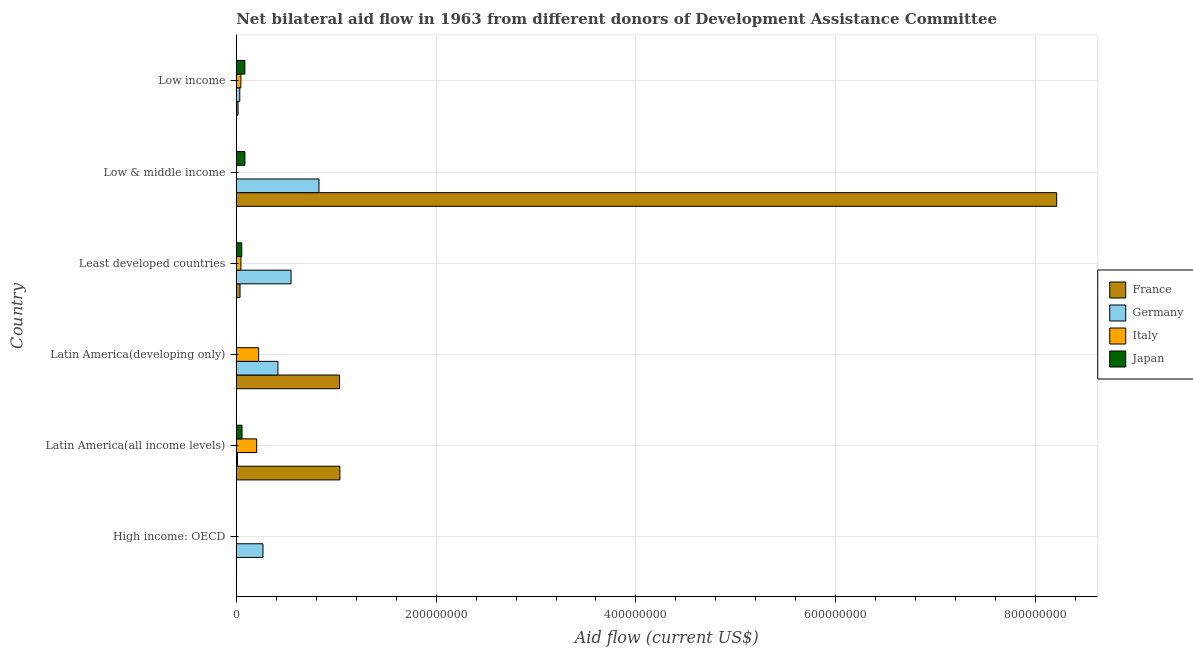How many different coloured bars are there?
Offer a terse response. 4. Are the number of bars on each tick of the Y-axis equal?
Give a very brief answer. Yes. How many bars are there on the 1st tick from the top?
Give a very brief answer. 4. How many bars are there on the 6th tick from the bottom?
Your response must be concise. 4. What is the label of the 3rd group of bars from the top?
Make the answer very short. Least developed countries. What is the amount of aid given by italy in Low income?
Offer a very short reply. 4.62e+06. Across all countries, what is the maximum amount of aid given by germany?
Offer a terse response. 8.28e+07. Across all countries, what is the minimum amount of aid given by japan?
Provide a short and direct response. 2.20e+05. In which country was the amount of aid given by germany minimum?
Your answer should be very brief. Latin America(all income levels). What is the total amount of aid given by france in the graph?
Make the answer very short. 1.03e+09. What is the difference between the amount of aid given by italy in Latin America(all income levels) and that in Latin America(developing only)?
Offer a very short reply. -1.97e+06. What is the difference between the amount of aid given by france in Low & middle income and the amount of aid given by italy in Low income?
Your answer should be compact. 8.16e+08. What is the average amount of aid given by france per country?
Provide a short and direct response. 1.72e+08. What is the difference between the amount of aid given by france and amount of aid given by italy in Least developed countries?
Provide a short and direct response. -8.70e+05. What is the ratio of the amount of aid given by germany in High income: OECD to that in Least developed countries?
Give a very brief answer. 0.49. Is the amount of aid given by italy in High income: OECD less than that in Least developed countries?
Your response must be concise. Yes. Is the difference between the amount of aid given by germany in Low & middle income and Low income greater than the difference between the amount of aid given by italy in Low & middle income and Low income?
Your answer should be very brief. Yes. What is the difference between the highest and the second highest amount of aid given by italy?
Ensure brevity in your answer.  1.97e+06. What is the difference between the highest and the lowest amount of aid given by japan?
Make the answer very short. 8.43e+06. In how many countries, is the amount of aid given by japan greater than the average amount of aid given by japan taken over all countries?
Provide a short and direct response. 4. Is it the case that in every country, the sum of the amount of aid given by germany and amount of aid given by france is greater than the sum of amount of aid given by italy and amount of aid given by japan?
Make the answer very short. Yes. Are all the bars in the graph horizontal?
Keep it short and to the point. Yes. Are the values on the major ticks of X-axis written in scientific E-notation?
Offer a terse response. No. How many legend labels are there?
Provide a short and direct response. 4. How are the legend labels stacked?
Ensure brevity in your answer.  Vertical. What is the title of the graph?
Make the answer very short. Net bilateral aid flow in 1963 from different donors of Development Assistance Committee. What is the Aid flow (current US$) in Germany in High income: OECD?
Offer a very short reply. 2.67e+07. What is the Aid flow (current US$) of France in Latin America(all income levels)?
Provide a short and direct response. 1.04e+08. What is the Aid flow (current US$) of Germany in Latin America(all income levels)?
Your response must be concise. 1.28e+06. What is the Aid flow (current US$) of Italy in Latin America(all income levels)?
Your answer should be compact. 2.04e+07. What is the Aid flow (current US$) in Japan in Latin America(all income levels)?
Your answer should be compact. 5.76e+06. What is the Aid flow (current US$) of France in Latin America(developing only)?
Your answer should be compact. 1.03e+08. What is the Aid flow (current US$) in Germany in Latin America(developing only)?
Provide a short and direct response. 4.17e+07. What is the Aid flow (current US$) in Italy in Latin America(developing only)?
Your response must be concise. 2.24e+07. What is the Aid flow (current US$) of France in Least developed countries?
Your response must be concise. 3.80e+06. What is the Aid flow (current US$) of Germany in Least developed countries?
Make the answer very short. 5.49e+07. What is the Aid flow (current US$) in Italy in Least developed countries?
Ensure brevity in your answer.  4.67e+06. What is the Aid flow (current US$) of Japan in Least developed countries?
Your answer should be very brief. 5.51e+06. What is the Aid flow (current US$) in France in Low & middle income?
Give a very brief answer. 8.21e+08. What is the Aid flow (current US$) of Germany in Low & middle income?
Make the answer very short. 8.28e+07. What is the Aid flow (current US$) of Japan in Low & middle income?
Your answer should be compact. 8.65e+06. What is the Aid flow (current US$) in France in Low income?
Your answer should be compact. 1.80e+06. What is the Aid flow (current US$) in Germany in Low income?
Provide a short and direct response. 3.53e+06. What is the Aid flow (current US$) of Italy in Low income?
Make the answer very short. 4.62e+06. What is the Aid flow (current US$) of Japan in Low income?
Your answer should be very brief. 8.62e+06. Across all countries, what is the maximum Aid flow (current US$) in France?
Give a very brief answer. 8.21e+08. Across all countries, what is the maximum Aid flow (current US$) in Germany?
Provide a succinct answer. 8.28e+07. Across all countries, what is the maximum Aid flow (current US$) of Italy?
Your response must be concise. 2.24e+07. Across all countries, what is the maximum Aid flow (current US$) in Japan?
Keep it short and to the point. 8.65e+06. Across all countries, what is the minimum Aid flow (current US$) in Germany?
Your answer should be compact. 1.28e+06. Across all countries, what is the minimum Aid flow (current US$) of Japan?
Your response must be concise. 2.20e+05. What is the total Aid flow (current US$) of France in the graph?
Your answer should be compact. 1.03e+09. What is the total Aid flow (current US$) in Germany in the graph?
Ensure brevity in your answer.  2.11e+08. What is the total Aid flow (current US$) in Italy in the graph?
Offer a very short reply. 5.23e+07. What is the total Aid flow (current US$) in Japan in the graph?
Ensure brevity in your answer.  2.90e+07. What is the difference between the Aid flow (current US$) of France in High income: OECD and that in Latin America(all income levels)?
Offer a very short reply. -1.03e+08. What is the difference between the Aid flow (current US$) of Germany in High income: OECD and that in Latin America(all income levels)?
Your answer should be compact. 2.55e+07. What is the difference between the Aid flow (current US$) of Italy in High income: OECD and that in Latin America(all income levels)?
Your response must be concise. -2.04e+07. What is the difference between the Aid flow (current US$) in Japan in High income: OECD and that in Latin America(all income levels)?
Give a very brief answer. -5.54e+06. What is the difference between the Aid flow (current US$) in France in High income: OECD and that in Latin America(developing only)?
Offer a terse response. -1.03e+08. What is the difference between the Aid flow (current US$) of Germany in High income: OECD and that in Latin America(developing only)?
Give a very brief answer. -1.50e+07. What is the difference between the Aid flow (current US$) in Italy in High income: OECD and that in Latin America(developing only)?
Offer a terse response. -2.23e+07. What is the difference between the Aid flow (current US$) in Japan in High income: OECD and that in Latin America(developing only)?
Provide a succinct answer. -3.00e+04. What is the difference between the Aid flow (current US$) in France in High income: OECD and that in Least developed countries?
Your answer should be very brief. -3.50e+06. What is the difference between the Aid flow (current US$) in Germany in High income: OECD and that in Least developed countries?
Offer a very short reply. -2.81e+07. What is the difference between the Aid flow (current US$) in Italy in High income: OECD and that in Least developed countries?
Offer a very short reply. -4.59e+06. What is the difference between the Aid flow (current US$) of Japan in High income: OECD and that in Least developed countries?
Offer a terse response. -5.29e+06. What is the difference between the Aid flow (current US$) in France in High income: OECD and that in Low & middle income?
Your response must be concise. -8.21e+08. What is the difference between the Aid flow (current US$) of Germany in High income: OECD and that in Low & middle income?
Provide a short and direct response. -5.61e+07. What is the difference between the Aid flow (current US$) of Italy in High income: OECD and that in Low & middle income?
Ensure brevity in your answer.  3.00e+04. What is the difference between the Aid flow (current US$) in Japan in High income: OECD and that in Low & middle income?
Offer a terse response. -8.43e+06. What is the difference between the Aid flow (current US$) of France in High income: OECD and that in Low income?
Make the answer very short. -1.50e+06. What is the difference between the Aid flow (current US$) in Germany in High income: OECD and that in Low income?
Provide a short and direct response. 2.32e+07. What is the difference between the Aid flow (current US$) of Italy in High income: OECD and that in Low income?
Keep it short and to the point. -4.54e+06. What is the difference between the Aid flow (current US$) in Japan in High income: OECD and that in Low income?
Offer a very short reply. -8.40e+06. What is the difference between the Aid flow (current US$) in France in Latin America(all income levels) and that in Latin America(developing only)?
Provide a short and direct response. 3.00e+05. What is the difference between the Aid flow (current US$) in Germany in Latin America(all income levels) and that in Latin America(developing only)?
Provide a succinct answer. -4.04e+07. What is the difference between the Aid flow (current US$) of Italy in Latin America(all income levels) and that in Latin America(developing only)?
Give a very brief answer. -1.97e+06. What is the difference between the Aid flow (current US$) of Japan in Latin America(all income levels) and that in Latin America(developing only)?
Keep it short and to the point. 5.51e+06. What is the difference between the Aid flow (current US$) in France in Latin America(all income levels) and that in Least developed countries?
Your response must be concise. 9.99e+07. What is the difference between the Aid flow (current US$) of Germany in Latin America(all income levels) and that in Least developed countries?
Provide a short and direct response. -5.36e+07. What is the difference between the Aid flow (current US$) of Italy in Latin America(all income levels) and that in Least developed countries?
Ensure brevity in your answer.  1.58e+07. What is the difference between the Aid flow (current US$) in Japan in Latin America(all income levels) and that in Least developed countries?
Your answer should be very brief. 2.50e+05. What is the difference between the Aid flow (current US$) of France in Latin America(all income levels) and that in Low & middle income?
Make the answer very short. -7.17e+08. What is the difference between the Aid flow (current US$) in Germany in Latin America(all income levels) and that in Low & middle income?
Provide a short and direct response. -8.15e+07. What is the difference between the Aid flow (current US$) in Italy in Latin America(all income levels) and that in Low & middle income?
Your answer should be compact. 2.04e+07. What is the difference between the Aid flow (current US$) of Japan in Latin America(all income levels) and that in Low & middle income?
Offer a terse response. -2.89e+06. What is the difference between the Aid flow (current US$) of France in Latin America(all income levels) and that in Low income?
Your answer should be compact. 1.02e+08. What is the difference between the Aid flow (current US$) of Germany in Latin America(all income levels) and that in Low income?
Provide a succinct answer. -2.25e+06. What is the difference between the Aid flow (current US$) of Italy in Latin America(all income levels) and that in Low income?
Offer a terse response. 1.58e+07. What is the difference between the Aid flow (current US$) of Japan in Latin America(all income levels) and that in Low income?
Offer a very short reply. -2.86e+06. What is the difference between the Aid flow (current US$) of France in Latin America(developing only) and that in Least developed countries?
Make the answer very short. 9.96e+07. What is the difference between the Aid flow (current US$) in Germany in Latin America(developing only) and that in Least developed countries?
Give a very brief answer. -1.32e+07. What is the difference between the Aid flow (current US$) of Italy in Latin America(developing only) and that in Least developed countries?
Your answer should be very brief. 1.78e+07. What is the difference between the Aid flow (current US$) in Japan in Latin America(developing only) and that in Least developed countries?
Offer a terse response. -5.26e+06. What is the difference between the Aid flow (current US$) of France in Latin America(developing only) and that in Low & middle income?
Give a very brief answer. -7.18e+08. What is the difference between the Aid flow (current US$) in Germany in Latin America(developing only) and that in Low & middle income?
Make the answer very short. -4.11e+07. What is the difference between the Aid flow (current US$) in Italy in Latin America(developing only) and that in Low & middle income?
Your response must be concise. 2.24e+07. What is the difference between the Aid flow (current US$) in Japan in Latin America(developing only) and that in Low & middle income?
Offer a very short reply. -8.40e+06. What is the difference between the Aid flow (current US$) in France in Latin America(developing only) and that in Low income?
Offer a terse response. 1.02e+08. What is the difference between the Aid flow (current US$) in Germany in Latin America(developing only) and that in Low income?
Ensure brevity in your answer.  3.82e+07. What is the difference between the Aid flow (current US$) of Italy in Latin America(developing only) and that in Low income?
Offer a terse response. 1.78e+07. What is the difference between the Aid flow (current US$) in Japan in Latin America(developing only) and that in Low income?
Make the answer very short. -8.37e+06. What is the difference between the Aid flow (current US$) of France in Least developed countries and that in Low & middle income?
Ensure brevity in your answer.  -8.17e+08. What is the difference between the Aid flow (current US$) in Germany in Least developed countries and that in Low & middle income?
Your answer should be compact. -2.79e+07. What is the difference between the Aid flow (current US$) in Italy in Least developed countries and that in Low & middle income?
Ensure brevity in your answer.  4.62e+06. What is the difference between the Aid flow (current US$) in Japan in Least developed countries and that in Low & middle income?
Keep it short and to the point. -3.14e+06. What is the difference between the Aid flow (current US$) in France in Least developed countries and that in Low income?
Your response must be concise. 2.00e+06. What is the difference between the Aid flow (current US$) in Germany in Least developed countries and that in Low income?
Offer a very short reply. 5.13e+07. What is the difference between the Aid flow (current US$) of Italy in Least developed countries and that in Low income?
Offer a terse response. 5.00e+04. What is the difference between the Aid flow (current US$) of Japan in Least developed countries and that in Low income?
Your response must be concise. -3.11e+06. What is the difference between the Aid flow (current US$) of France in Low & middle income and that in Low income?
Offer a terse response. 8.19e+08. What is the difference between the Aid flow (current US$) in Germany in Low & middle income and that in Low income?
Your answer should be very brief. 7.93e+07. What is the difference between the Aid flow (current US$) in Italy in Low & middle income and that in Low income?
Keep it short and to the point. -4.57e+06. What is the difference between the Aid flow (current US$) in France in High income: OECD and the Aid flow (current US$) in Germany in Latin America(all income levels)?
Keep it short and to the point. -9.80e+05. What is the difference between the Aid flow (current US$) of France in High income: OECD and the Aid flow (current US$) of Italy in Latin America(all income levels)?
Provide a succinct answer. -2.02e+07. What is the difference between the Aid flow (current US$) in France in High income: OECD and the Aid flow (current US$) in Japan in Latin America(all income levels)?
Your response must be concise. -5.46e+06. What is the difference between the Aid flow (current US$) in Germany in High income: OECD and the Aid flow (current US$) in Italy in Latin America(all income levels)?
Give a very brief answer. 6.29e+06. What is the difference between the Aid flow (current US$) of Germany in High income: OECD and the Aid flow (current US$) of Japan in Latin America(all income levels)?
Your answer should be very brief. 2.10e+07. What is the difference between the Aid flow (current US$) of Italy in High income: OECD and the Aid flow (current US$) of Japan in Latin America(all income levels)?
Your answer should be very brief. -5.68e+06. What is the difference between the Aid flow (current US$) in France in High income: OECD and the Aid flow (current US$) in Germany in Latin America(developing only)?
Give a very brief answer. -4.14e+07. What is the difference between the Aid flow (current US$) in France in High income: OECD and the Aid flow (current US$) in Italy in Latin America(developing only)?
Make the answer very short. -2.21e+07. What is the difference between the Aid flow (current US$) of Germany in High income: OECD and the Aid flow (current US$) of Italy in Latin America(developing only)?
Provide a succinct answer. 4.32e+06. What is the difference between the Aid flow (current US$) in Germany in High income: OECD and the Aid flow (current US$) in Japan in Latin America(developing only)?
Give a very brief answer. 2.65e+07. What is the difference between the Aid flow (current US$) in France in High income: OECD and the Aid flow (current US$) in Germany in Least developed countries?
Offer a terse response. -5.46e+07. What is the difference between the Aid flow (current US$) in France in High income: OECD and the Aid flow (current US$) in Italy in Least developed countries?
Offer a terse response. -4.37e+06. What is the difference between the Aid flow (current US$) in France in High income: OECD and the Aid flow (current US$) in Japan in Least developed countries?
Your answer should be compact. -5.21e+06. What is the difference between the Aid flow (current US$) in Germany in High income: OECD and the Aid flow (current US$) in Italy in Least developed countries?
Provide a succinct answer. 2.21e+07. What is the difference between the Aid flow (current US$) of Germany in High income: OECD and the Aid flow (current US$) of Japan in Least developed countries?
Keep it short and to the point. 2.12e+07. What is the difference between the Aid flow (current US$) of Italy in High income: OECD and the Aid flow (current US$) of Japan in Least developed countries?
Provide a succinct answer. -5.43e+06. What is the difference between the Aid flow (current US$) of France in High income: OECD and the Aid flow (current US$) of Germany in Low & middle income?
Provide a succinct answer. -8.25e+07. What is the difference between the Aid flow (current US$) in France in High income: OECD and the Aid flow (current US$) in Japan in Low & middle income?
Keep it short and to the point. -8.35e+06. What is the difference between the Aid flow (current US$) in Germany in High income: OECD and the Aid flow (current US$) in Italy in Low & middle income?
Provide a short and direct response. 2.67e+07. What is the difference between the Aid flow (current US$) in Germany in High income: OECD and the Aid flow (current US$) in Japan in Low & middle income?
Offer a terse response. 1.81e+07. What is the difference between the Aid flow (current US$) of Italy in High income: OECD and the Aid flow (current US$) of Japan in Low & middle income?
Ensure brevity in your answer.  -8.57e+06. What is the difference between the Aid flow (current US$) of France in High income: OECD and the Aid flow (current US$) of Germany in Low income?
Provide a succinct answer. -3.23e+06. What is the difference between the Aid flow (current US$) of France in High income: OECD and the Aid flow (current US$) of Italy in Low income?
Keep it short and to the point. -4.32e+06. What is the difference between the Aid flow (current US$) of France in High income: OECD and the Aid flow (current US$) of Japan in Low income?
Give a very brief answer. -8.32e+06. What is the difference between the Aid flow (current US$) in Germany in High income: OECD and the Aid flow (current US$) in Italy in Low income?
Offer a very short reply. 2.21e+07. What is the difference between the Aid flow (current US$) of Germany in High income: OECD and the Aid flow (current US$) of Japan in Low income?
Give a very brief answer. 1.81e+07. What is the difference between the Aid flow (current US$) in Italy in High income: OECD and the Aid flow (current US$) in Japan in Low income?
Offer a very short reply. -8.54e+06. What is the difference between the Aid flow (current US$) of France in Latin America(all income levels) and the Aid flow (current US$) of Germany in Latin America(developing only)?
Keep it short and to the point. 6.20e+07. What is the difference between the Aid flow (current US$) in France in Latin America(all income levels) and the Aid flow (current US$) in Italy in Latin America(developing only)?
Your answer should be compact. 8.13e+07. What is the difference between the Aid flow (current US$) in France in Latin America(all income levels) and the Aid flow (current US$) in Japan in Latin America(developing only)?
Offer a very short reply. 1.03e+08. What is the difference between the Aid flow (current US$) of Germany in Latin America(all income levels) and the Aid flow (current US$) of Italy in Latin America(developing only)?
Offer a very short reply. -2.11e+07. What is the difference between the Aid flow (current US$) in Germany in Latin America(all income levels) and the Aid flow (current US$) in Japan in Latin America(developing only)?
Give a very brief answer. 1.03e+06. What is the difference between the Aid flow (current US$) in Italy in Latin America(all income levels) and the Aid flow (current US$) in Japan in Latin America(developing only)?
Offer a terse response. 2.02e+07. What is the difference between the Aid flow (current US$) in France in Latin America(all income levels) and the Aid flow (current US$) in Germany in Least developed countries?
Provide a succinct answer. 4.88e+07. What is the difference between the Aid flow (current US$) in France in Latin America(all income levels) and the Aid flow (current US$) in Italy in Least developed countries?
Make the answer very short. 9.90e+07. What is the difference between the Aid flow (current US$) of France in Latin America(all income levels) and the Aid flow (current US$) of Japan in Least developed countries?
Offer a terse response. 9.82e+07. What is the difference between the Aid flow (current US$) of Germany in Latin America(all income levels) and the Aid flow (current US$) of Italy in Least developed countries?
Your answer should be very brief. -3.39e+06. What is the difference between the Aid flow (current US$) of Germany in Latin America(all income levels) and the Aid flow (current US$) of Japan in Least developed countries?
Provide a succinct answer. -4.23e+06. What is the difference between the Aid flow (current US$) in Italy in Latin America(all income levels) and the Aid flow (current US$) in Japan in Least developed countries?
Ensure brevity in your answer.  1.49e+07. What is the difference between the Aid flow (current US$) in France in Latin America(all income levels) and the Aid flow (current US$) in Germany in Low & middle income?
Give a very brief answer. 2.09e+07. What is the difference between the Aid flow (current US$) in France in Latin America(all income levels) and the Aid flow (current US$) in Italy in Low & middle income?
Your response must be concise. 1.04e+08. What is the difference between the Aid flow (current US$) of France in Latin America(all income levels) and the Aid flow (current US$) of Japan in Low & middle income?
Provide a short and direct response. 9.50e+07. What is the difference between the Aid flow (current US$) of Germany in Latin America(all income levels) and the Aid flow (current US$) of Italy in Low & middle income?
Your response must be concise. 1.23e+06. What is the difference between the Aid flow (current US$) in Germany in Latin America(all income levels) and the Aid flow (current US$) in Japan in Low & middle income?
Make the answer very short. -7.37e+06. What is the difference between the Aid flow (current US$) in Italy in Latin America(all income levels) and the Aid flow (current US$) in Japan in Low & middle income?
Keep it short and to the point. 1.18e+07. What is the difference between the Aid flow (current US$) of France in Latin America(all income levels) and the Aid flow (current US$) of Germany in Low income?
Keep it short and to the point. 1.00e+08. What is the difference between the Aid flow (current US$) of France in Latin America(all income levels) and the Aid flow (current US$) of Italy in Low income?
Provide a succinct answer. 9.91e+07. What is the difference between the Aid flow (current US$) in France in Latin America(all income levels) and the Aid flow (current US$) in Japan in Low income?
Give a very brief answer. 9.51e+07. What is the difference between the Aid flow (current US$) in Germany in Latin America(all income levels) and the Aid flow (current US$) in Italy in Low income?
Your answer should be compact. -3.34e+06. What is the difference between the Aid flow (current US$) of Germany in Latin America(all income levels) and the Aid flow (current US$) of Japan in Low income?
Provide a short and direct response. -7.34e+06. What is the difference between the Aid flow (current US$) in Italy in Latin America(all income levels) and the Aid flow (current US$) in Japan in Low income?
Provide a succinct answer. 1.18e+07. What is the difference between the Aid flow (current US$) of France in Latin America(developing only) and the Aid flow (current US$) of Germany in Least developed countries?
Ensure brevity in your answer.  4.85e+07. What is the difference between the Aid flow (current US$) of France in Latin America(developing only) and the Aid flow (current US$) of Italy in Least developed countries?
Offer a terse response. 9.87e+07. What is the difference between the Aid flow (current US$) in France in Latin America(developing only) and the Aid flow (current US$) in Japan in Least developed countries?
Keep it short and to the point. 9.79e+07. What is the difference between the Aid flow (current US$) in Germany in Latin America(developing only) and the Aid flow (current US$) in Italy in Least developed countries?
Offer a very short reply. 3.70e+07. What is the difference between the Aid flow (current US$) of Germany in Latin America(developing only) and the Aid flow (current US$) of Japan in Least developed countries?
Your answer should be compact. 3.62e+07. What is the difference between the Aid flow (current US$) of Italy in Latin America(developing only) and the Aid flow (current US$) of Japan in Least developed countries?
Give a very brief answer. 1.69e+07. What is the difference between the Aid flow (current US$) of France in Latin America(developing only) and the Aid flow (current US$) of Germany in Low & middle income?
Your answer should be very brief. 2.06e+07. What is the difference between the Aid flow (current US$) of France in Latin America(developing only) and the Aid flow (current US$) of Italy in Low & middle income?
Your answer should be very brief. 1.03e+08. What is the difference between the Aid flow (current US$) of France in Latin America(developing only) and the Aid flow (current US$) of Japan in Low & middle income?
Give a very brief answer. 9.48e+07. What is the difference between the Aid flow (current US$) in Germany in Latin America(developing only) and the Aid flow (current US$) in Italy in Low & middle income?
Your response must be concise. 4.16e+07. What is the difference between the Aid flow (current US$) in Germany in Latin America(developing only) and the Aid flow (current US$) in Japan in Low & middle income?
Provide a short and direct response. 3.30e+07. What is the difference between the Aid flow (current US$) of Italy in Latin America(developing only) and the Aid flow (current US$) of Japan in Low & middle income?
Ensure brevity in your answer.  1.38e+07. What is the difference between the Aid flow (current US$) of France in Latin America(developing only) and the Aid flow (current US$) of Germany in Low income?
Offer a very short reply. 9.99e+07. What is the difference between the Aid flow (current US$) of France in Latin America(developing only) and the Aid flow (current US$) of Italy in Low income?
Your response must be concise. 9.88e+07. What is the difference between the Aid flow (current US$) in France in Latin America(developing only) and the Aid flow (current US$) in Japan in Low income?
Your answer should be very brief. 9.48e+07. What is the difference between the Aid flow (current US$) of Germany in Latin America(developing only) and the Aid flow (current US$) of Italy in Low income?
Give a very brief answer. 3.71e+07. What is the difference between the Aid flow (current US$) in Germany in Latin America(developing only) and the Aid flow (current US$) in Japan in Low income?
Provide a short and direct response. 3.31e+07. What is the difference between the Aid flow (current US$) in Italy in Latin America(developing only) and the Aid flow (current US$) in Japan in Low income?
Keep it short and to the point. 1.38e+07. What is the difference between the Aid flow (current US$) of France in Least developed countries and the Aid flow (current US$) of Germany in Low & middle income?
Ensure brevity in your answer.  -7.90e+07. What is the difference between the Aid flow (current US$) of France in Least developed countries and the Aid flow (current US$) of Italy in Low & middle income?
Your answer should be very brief. 3.75e+06. What is the difference between the Aid flow (current US$) in France in Least developed countries and the Aid flow (current US$) in Japan in Low & middle income?
Your answer should be very brief. -4.85e+06. What is the difference between the Aid flow (current US$) in Germany in Least developed countries and the Aid flow (current US$) in Italy in Low & middle income?
Make the answer very short. 5.48e+07. What is the difference between the Aid flow (current US$) in Germany in Least developed countries and the Aid flow (current US$) in Japan in Low & middle income?
Offer a very short reply. 4.62e+07. What is the difference between the Aid flow (current US$) in Italy in Least developed countries and the Aid flow (current US$) in Japan in Low & middle income?
Your answer should be compact. -3.98e+06. What is the difference between the Aid flow (current US$) of France in Least developed countries and the Aid flow (current US$) of Italy in Low income?
Give a very brief answer. -8.20e+05. What is the difference between the Aid flow (current US$) in France in Least developed countries and the Aid flow (current US$) in Japan in Low income?
Your answer should be very brief. -4.82e+06. What is the difference between the Aid flow (current US$) in Germany in Least developed countries and the Aid flow (current US$) in Italy in Low income?
Keep it short and to the point. 5.02e+07. What is the difference between the Aid flow (current US$) of Germany in Least developed countries and the Aid flow (current US$) of Japan in Low income?
Provide a succinct answer. 4.62e+07. What is the difference between the Aid flow (current US$) in Italy in Least developed countries and the Aid flow (current US$) in Japan in Low income?
Offer a terse response. -3.95e+06. What is the difference between the Aid flow (current US$) of France in Low & middle income and the Aid flow (current US$) of Germany in Low income?
Ensure brevity in your answer.  8.18e+08. What is the difference between the Aid flow (current US$) in France in Low & middle income and the Aid flow (current US$) in Italy in Low income?
Your answer should be very brief. 8.16e+08. What is the difference between the Aid flow (current US$) in France in Low & middle income and the Aid flow (current US$) in Japan in Low income?
Provide a short and direct response. 8.12e+08. What is the difference between the Aid flow (current US$) of Germany in Low & middle income and the Aid flow (current US$) of Italy in Low income?
Offer a very short reply. 7.82e+07. What is the difference between the Aid flow (current US$) in Germany in Low & middle income and the Aid flow (current US$) in Japan in Low income?
Your answer should be very brief. 7.42e+07. What is the difference between the Aid flow (current US$) of Italy in Low & middle income and the Aid flow (current US$) of Japan in Low income?
Your answer should be very brief. -8.57e+06. What is the average Aid flow (current US$) in France per country?
Offer a very short reply. 1.72e+08. What is the average Aid flow (current US$) of Germany per country?
Make the answer very short. 3.52e+07. What is the average Aid flow (current US$) in Italy per country?
Keep it short and to the point. 8.72e+06. What is the average Aid flow (current US$) of Japan per country?
Provide a succinct answer. 4.84e+06. What is the difference between the Aid flow (current US$) of France and Aid flow (current US$) of Germany in High income: OECD?
Provide a succinct answer. -2.64e+07. What is the difference between the Aid flow (current US$) in Germany and Aid flow (current US$) in Italy in High income: OECD?
Give a very brief answer. 2.67e+07. What is the difference between the Aid flow (current US$) of Germany and Aid flow (current US$) of Japan in High income: OECD?
Your answer should be very brief. 2.65e+07. What is the difference between the Aid flow (current US$) in Italy and Aid flow (current US$) in Japan in High income: OECD?
Your answer should be very brief. -1.40e+05. What is the difference between the Aid flow (current US$) in France and Aid flow (current US$) in Germany in Latin America(all income levels)?
Give a very brief answer. 1.02e+08. What is the difference between the Aid flow (current US$) in France and Aid flow (current US$) in Italy in Latin America(all income levels)?
Keep it short and to the point. 8.32e+07. What is the difference between the Aid flow (current US$) in France and Aid flow (current US$) in Japan in Latin America(all income levels)?
Ensure brevity in your answer.  9.79e+07. What is the difference between the Aid flow (current US$) of Germany and Aid flow (current US$) of Italy in Latin America(all income levels)?
Your answer should be compact. -1.92e+07. What is the difference between the Aid flow (current US$) of Germany and Aid flow (current US$) of Japan in Latin America(all income levels)?
Make the answer very short. -4.48e+06. What is the difference between the Aid flow (current US$) in Italy and Aid flow (current US$) in Japan in Latin America(all income levels)?
Provide a succinct answer. 1.47e+07. What is the difference between the Aid flow (current US$) of France and Aid flow (current US$) of Germany in Latin America(developing only)?
Offer a very short reply. 6.17e+07. What is the difference between the Aid flow (current US$) of France and Aid flow (current US$) of Italy in Latin America(developing only)?
Keep it short and to the point. 8.10e+07. What is the difference between the Aid flow (current US$) in France and Aid flow (current US$) in Japan in Latin America(developing only)?
Offer a very short reply. 1.03e+08. What is the difference between the Aid flow (current US$) in Germany and Aid flow (current US$) in Italy in Latin America(developing only)?
Provide a short and direct response. 1.93e+07. What is the difference between the Aid flow (current US$) in Germany and Aid flow (current US$) in Japan in Latin America(developing only)?
Keep it short and to the point. 4.14e+07. What is the difference between the Aid flow (current US$) in Italy and Aid flow (current US$) in Japan in Latin America(developing only)?
Make the answer very short. 2.22e+07. What is the difference between the Aid flow (current US$) of France and Aid flow (current US$) of Germany in Least developed countries?
Offer a very short reply. -5.11e+07. What is the difference between the Aid flow (current US$) in France and Aid flow (current US$) in Italy in Least developed countries?
Give a very brief answer. -8.70e+05. What is the difference between the Aid flow (current US$) in France and Aid flow (current US$) in Japan in Least developed countries?
Make the answer very short. -1.71e+06. What is the difference between the Aid flow (current US$) in Germany and Aid flow (current US$) in Italy in Least developed countries?
Your answer should be very brief. 5.02e+07. What is the difference between the Aid flow (current US$) of Germany and Aid flow (current US$) of Japan in Least developed countries?
Keep it short and to the point. 4.94e+07. What is the difference between the Aid flow (current US$) in Italy and Aid flow (current US$) in Japan in Least developed countries?
Provide a short and direct response. -8.40e+05. What is the difference between the Aid flow (current US$) of France and Aid flow (current US$) of Germany in Low & middle income?
Provide a short and direct response. 7.38e+08. What is the difference between the Aid flow (current US$) of France and Aid flow (current US$) of Italy in Low & middle income?
Your response must be concise. 8.21e+08. What is the difference between the Aid flow (current US$) in France and Aid flow (current US$) in Japan in Low & middle income?
Your answer should be compact. 8.12e+08. What is the difference between the Aid flow (current US$) in Germany and Aid flow (current US$) in Italy in Low & middle income?
Offer a very short reply. 8.28e+07. What is the difference between the Aid flow (current US$) of Germany and Aid flow (current US$) of Japan in Low & middle income?
Provide a short and direct response. 7.42e+07. What is the difference between the Aid flow (current US$) in Italy and Aid flow (current US$) in Japan in Low & middle income?
Your answer should be compact. -8.60e+06. What is the difference between the Aid flow (current US$) in France and Aid flow (current US$) in Germany in Low income?
Your response must be concise. -1.73e+06. What is the difference between the Aid flow (current US$) of France and Aid flow (current US$) of Italy in Low income?
Your answer should be very brief. -2.82e+06. What is the difference between the Aid flow (current US$) in France and Aid flow (current US$) in Japan in Low income?
Provide a succinct answer. -6.82e+06. What is the difference between the Aid flow (current US$) of Germany and Aid flow (current US$) of Italy in Low income?
Your response must be concise. -1.09e+06. What is the difference between the Aid flow (current US$) of Germany and Aid flow (current US$) of Japan in Low income?
Offer a terse response. -5.09e+06. What is the difference between the Aid flow (current US$) of Italy and Aid flow (current US$) of Japan in Low income?
Ensure brevity in your answer.  -4.00e+06. What is the ratio of the Aid flow (current US$) in France in High income: OECD to that in Latin America(all income levels)?
Keep it short and to the point. 0. What is the ratio of the Aid flow (current US$) of Germany in High income: OECD to that in Latin America(all income levels)?
Keep it short and to the point. 20.89. What is the ratio of the Aid flow (current US$) of Italy in High income: OECD to that in Latin America(all income levels)?
Your answer should be very brief. 0. What is the ratio of the Aid flow (current US$) in Japan in High income: OECD to that in Latin America(all income levels)?
Make the answer very short. 0.04. What is the ratio of the Aid flow (current US$) in France in High income: OECD to that in Latin America(developing only)?
Ensure brevity in your answer.  0. What is the ratio of the Aid flow (current US$) in Germany in High income: OECD to that in Latin America(developing only)?
Your answer should be compact. 0.64. What is the ratio of the Aid flow (current US$) of Italy in High income: OECD to that in Latin America(developing only)?
Ensure brevity in your answer.  0. What is the ratio of the Aid flow (current US$) of Japan in High income: OECD to that in Latin America(developing only)?
Provide a short and direct response. 0.88. What is the ratio of the Aid flow (current US$) of France in High income: OECD to that in Least developed countries?
Your answer should be compact. 0.08. What is the ratio of the Aid flow (current US$) of Germany in High income: OECD to that in Least developed countries?
Your answer should be compact. 0.49. What is the ratio of the Aid flow (current US$) of Italy in High income: OECD to that in Least developed countries?
Your response must be concise. 0.02. What is the ratio of the Aid flow (current US$) of Japan in High income: OECD to that in Least developed countries?
Give a very brief answer. 0.04. What is the ratio of the Aid flow (current US$) of France in High income: OECD to that in Low & middle income?
Give a very brief answer. 0. What is the ratio of the Aid flow (current US$) of Germany in High income: OECD to that in Low & middle income?
Offer a terse response. 0.32. What is the ratio of the Aid flow (current US$) in Italy in High income: OECD to that in Low & middle income?
Provide a succinct answer. 1.6. What is the ratio of the Aid flow (current US$) of Japan in High income: OECD to that in Low & middle income?
Make the answer very short. 0.03. What is the ratio of the Aid flow (current US$) of France in High income: OECD to that in Low income?
Provide a succinct answer. 0.17. What is the ratio of the Aid flow (current US$) in Germany in High income: OECD to that in Low income?
Keep it short and to the point. 7.58. What is the ratio of the Aid flow (current US$) of Italy in High income: OECD to that in Low income?
Give a very brief answer. 0.02. What is the ratio of the Aid flow (current US$) in Japan in High income: OECD to that in Low income?
Offer a very short reply. 0.03. What is the ratio of the Aid flow (current US$) in France in Latin America(all income levels) to that in Latin America(developing only)?
Your response must be concise. 1. What is the ratio of the Aid flow (current US$) of Germany in Latin America(all income levels) to that in Latin America(developing only)?
Make the answer very short. 0.03. What is the ratio of the Aid flow (current US$) of Italy in Latin America(all income levels) to that in Latin America(developing only)?
Keep it short and to the point. 0.91. What is the ratio of the Aid flow (current US$) in Japan in Latin America(all income levels) to that in Latin America(developing only)?
Offer a very short reply. 23.04. What is the ratio of the Aid flow (current US$) in France in Latin America(all income levels) to that in Least developed countries?
Give a very brief answer. 27.29. What is the ratio of the Aid flow (current US$) of Germany in Latin America(all income levels) to that in Least developed countries?
Provide a short and direct response. 0.02. What is the ratio of the Aid flow (current US$) of Italy in Latin America(all income levels) to that in Least developed countries?
Keep it short and to the point. 4.38. What is the ratio of the Aid flow (current US$) in Japan in Latin America(all income levels) to that in Least developed countries?
Your answer should be very brief. 1.05. What is the ratio of the Aid flow (current US$) in France in Latin America(all income levels) to that in Low & middle income?
Offer a terse response. 0.13. What is the ratio of the Aid flow (current US$) in Germany in Latin America(all income levels) to that in Low & middle income?
Your answer should be compact. 0.02. What is the ratio of the Aid flow (current US$) in Italy in Latin America(all income levels) to that in Low & middle income?
Give a very brief answer. 409. What is the ratio of the Aid flow (current US$) of Japan in Latin America(all income levels) to that in Low & middle income?
Provide a short and direct response. 0.67. What is the ratio of the Aid flow (current US$) of France in Latin America(all income levels) to that in Low income?
Offer a very short reply. 57.61. What is the ratio of the Aid flow (current US$) of Germany in Latin America(all income levels) to that in Low income?
Give a very brief answer. 0.36. What is the ratio of the Aid flow (current US$) of Italy in Latin America(all income levels) to that in Low income?
Provide a short and direct response. 4.43. What is the ratio of the Aid flow (current US$) of Japan in Latin America(all income levels) to that in Low income?
Give a very brief answer. 0.67. What is the ratio of the Aid flow (current US$) in France in Latin America(developing only) to that in Least developed countries?
Your answer should be very brief. 27.21. What is the ratio of the Aid flow (current US$) of Germany in Latin America(developing only) to that in Least developed countries?
Make the answer very short. 0.76. What is the ratio of the Aid flow (current US$) in Italy in Latin America(developing only) to that in Least developed countries?
Provide a succinct answer. 4.8. What is the ratio of the Aid flow (current US$) of Japan in Latin America(developing only) to that in Least developed countries?
Your answer should be compact. 0.05. What is the ratio of the Aid flow (current US$) of France in Latin America(developing only) to that in Low & middle income?
Make the answer very short. 0.13. What is the ratio of the Aid flow (current US$) of Germany in Latin America(developing only) to that in Low & middle income?
Offer a terse response. 0.5. What is the ratio of the Aid flow (current US$) of Italy in Latin America(developing only) to that in Low & middle income?
Give a very brief answer. 448.4. What is the ratio of the Aid flow (current US$) in Japan in Latin America(developing only) to that in Low & middle income?
Offer a terse response. 0.03. What is the ratio of the Aid flow (current US$) in France in Latin America(developing only) to that in Low income?
Offer a terse response. 57.44. What is the ratio of the Aid flow (current US$) in Germany in Latin America(developing only) to that in Low income?
Your answer should be compact. 11.81. What is the ratio of the Aid flow (current US$) in Italy in Latin America(developing only) to that in Low income?
Provide a succinct answer. 4.85. What is the ratio of the Aid flow (current US$) of Japan in Latin America(developing only) to that in Low income?
Keep it short and to the point. 0.03. What is the ratio of the Aid flow (current US$) in France in Least developed countries to that in Low & middle income?
Make the answer very short. 0. What is the ratio of the Aid flow (current US$) of Germany in Least developed countries to that in Low & middle income?
Keep it short and to the point. 0.66. What is the ratio of the Aid flow (current US$) of Italy in Least developed countries to that in Low & middle income?
Keep it short and to the point. 93.4. What is the ratio of the Aid flow (current US$) in Japan in Least developed countries to that in Low & middle income?
Your answer should be compact. 0.64. What is the ratio of the Aid flow (current US$) of France in Least developed countries to that in Low income?
Provide a short and direct response. 2.11. What is the ratio of the Aid flow (current US$) of Germany in Least developed countries to that in Low income?
Keep it short and to the point. 15.54. What is the ratio of the Aid flow (current US$) in Italy in Least developed countries to that in Low income?
Your response must be concise. 1.01. What is the ratio of the Aid flow (current US$) of Japan in Least developed countries to that in Low income?
Make the answer very short. 0.64. What is the ratio of the Aid flow (current US$) in France in Low & middle income to that in Low income?
Make the answer very short. 456.17. What is the ratio of the Aid flow (current US$) of Germany in Low & middle income to that in Low income?
Provide a succinct answer. 23.46. What is the ratio of the Aid flow (current US$) of Italy in Low & middle income to that in Low income?
Ensure brevity in your answer.  0.01. What is the difference between the highest and the second highest Aid flow (current US$) of France?
Your response must be concise. 7.17e+08. What is the difference between the highest and the second highest Aid flow (current US$) in Germany?
Make the answer very short. 2.79e+07. What is the difference between the highest and the second highest Aid flow (current US$) in Italy?
Keep it short and to the point. 1.97e+06. What is the difference between the highest and the lowest Aid flow (current US$) of France?
Provide a succinct answer. 8.21e+08. What is the difference between the highest and the lowest Aid flow (current US$) of Germany?
Ensure brevity in your answer.  8.15e+07. What is the difference between the highest and the lowest Aid flow (current US$) in Italy?
Offer a very short reply. 2.24e+07. What is the difference between the highest and the lowest Aid flow (current US$) of Japan?
Offer a terse response. 8.43e+06. 